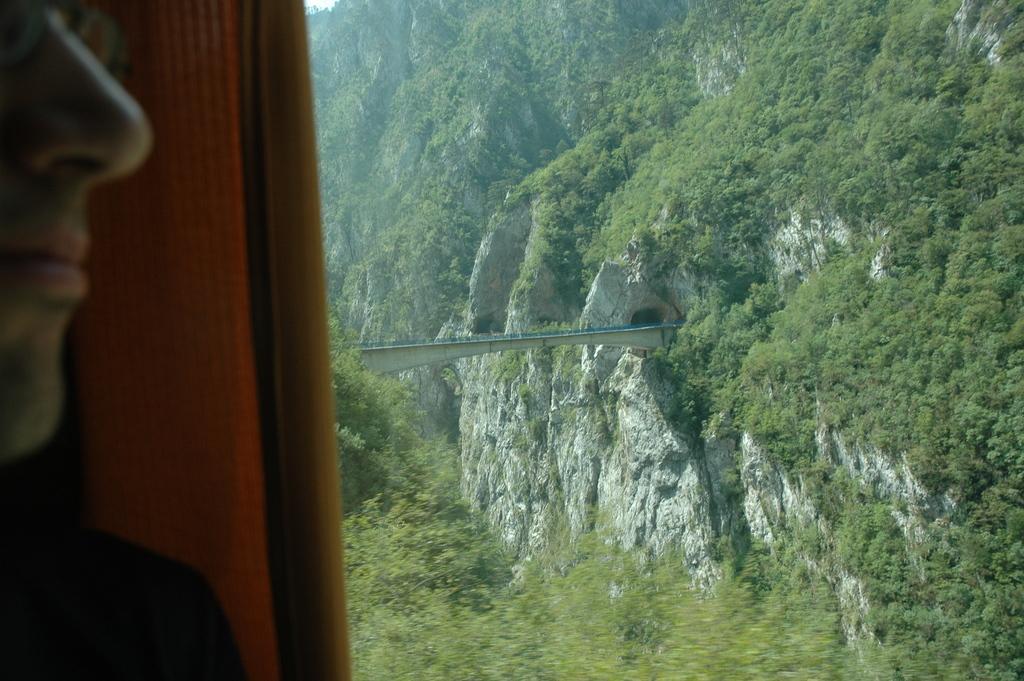Can you describe this image briefly? In this image there is a person standing behind the wall. In the background there is a mountain, and with some trees. There is a bridge in between the mountains. 